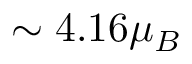<formula> <loc_0><loc_0><loc_500><loc_500>\sim { 4 . 1 6 } \mu _ { B }</formula> 